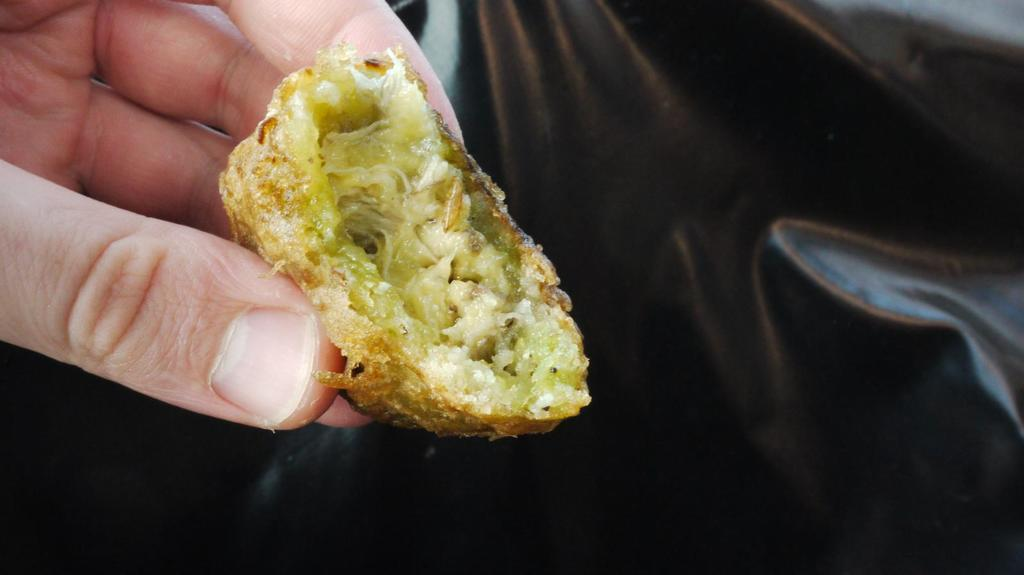What is being held by the hands in the image? There are hands holding an edible in the image. What can be observed about the background of the image? The background of the image is black or appears black. What type of map can be seen in the image? There is no map present in the image. How does the stomach appear in the image? There is no stomach visible in the image. 